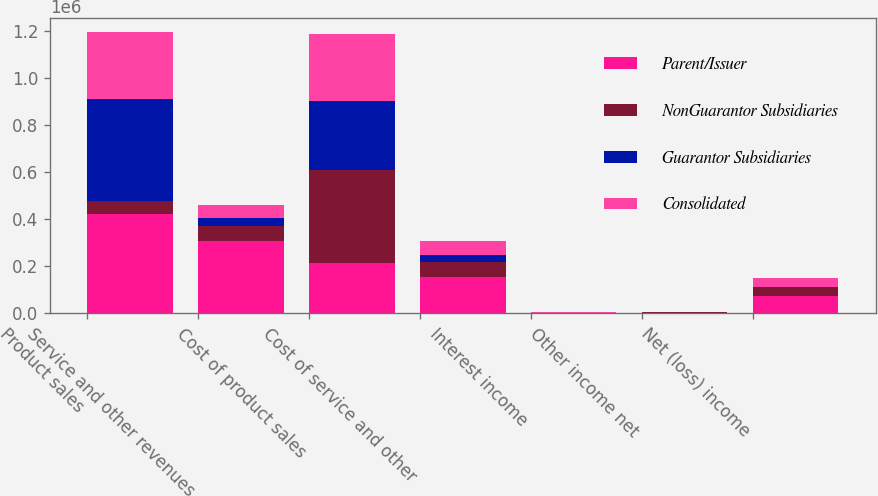Convert chart to OTSL. <chart><loc_0><loc_0><loc_500><loc_500><stacked_bar_chart><ecel><fcel>Product sales<fcel>Service and other revenues<fcel>Cost of product sales<fcel>Cost of service and other<fcel>Interest income<fcel>Other income net<fcel>Net (loss) income<nl><fcel>Parent/Issuer<fcel>420960<fcel>307097<fcel>211665<fcel>155555<fcel>1950<fcel>3051<fcel>73634<nl><fcel>NonGuarantor Subsidiaries<fcel>58041<fcel>63313<fcel>396747<fcel>61285<fcel>159<fcel>699<fcel>37385<nl><fcel>Guarantor Subsidiaries<fcel>431689<fcel>32555<fcel>292928<fcel>30713<fcel>840<fcel>557<fcel>2640<nl><fcel>Consolidated<fcel>284501<fcel>58041<fcel>284501<fcel>58041<fcel>609<fcel>609<fcel>34745<nl></chart> 